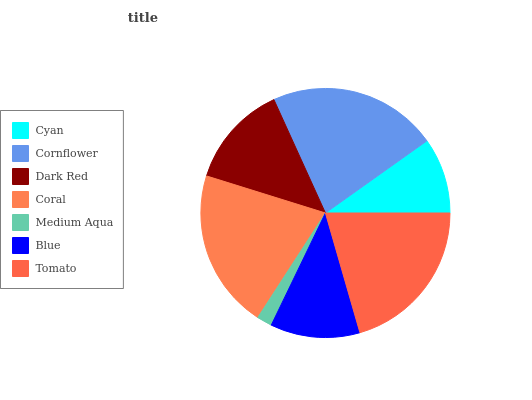Is Medium Aqua the minimum?
Answer yes or no. Yes. Is Cornflower the maximum?
Answer yes or no. Yes. Is Dark Red the minimum?
Answer yes or no. No. Is Dark Red the maximum?
Answer yes or no. No. Is Cornflower greater than Dark Red?
Answer yes or no. Yes. Is Dark Red less than Cornflower?
Answer yes or no. Yes. Is Dark Red greater than Cornflower?
Answer yes or no. No. Is Cornflower less than Dark Red?
Answer yes or no. No. Is Dark Red the high median?
Answer yes or no. Yes. Is Dark Red the low median?
Answer yes or no. Yes. Is Medium Aqua the high median?
Answer yes or no. No. Is Coral the low median?
Answer yes or no. No. 